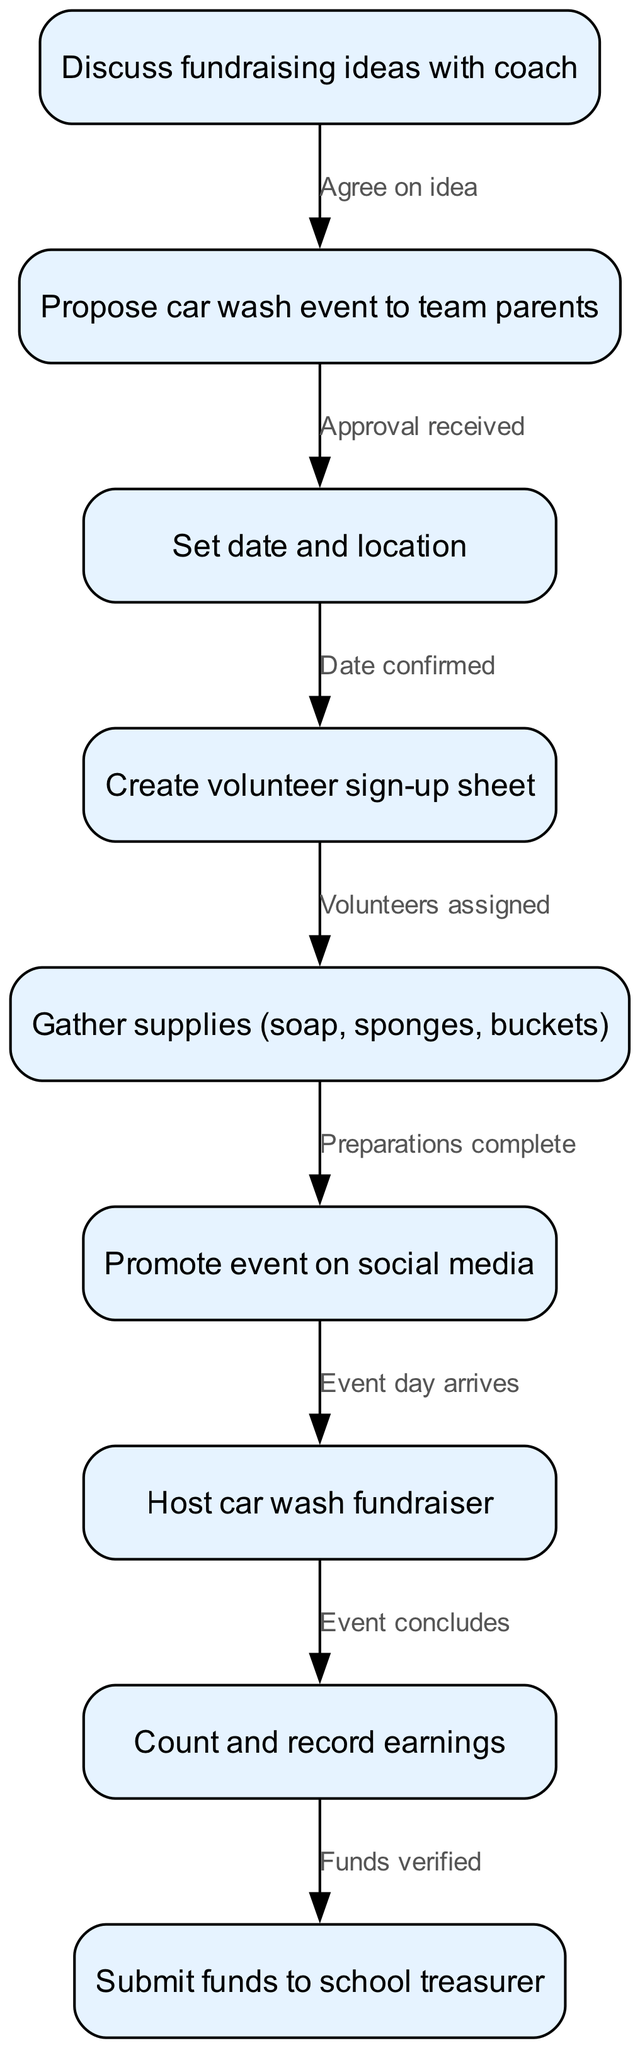What is the first step in organizing the fundraising event? The diagram indicates that the first step involves discussing fundraising ideas with the coach. This is represented as the initial node in the flowchart.
Answer: Discuss fundraising ideas with coach How many nodes are there in the diagram? To find the number of nodes, we can count each distinct action or step listed in the nodes section of the diagram. There are a total of nine nodes.
Answer: 9 What is the last action taken after hosting the car wash fundraiser? The final action in the flowchart after hosting the car wash fundraiser is counting and recording the earnings. This is shown as the last step before submitting the funds.
Answer: Count and record earnings What happens after proposing the car wash event to team parents? After proposing the car wash event to team parents, the next step is to receive approval for the event. This transition is marked by the edge connecting these two nodes.
Answer: Approval received Which step occurs directly after creating a volunteer sign-up sheet? According to the diagram, the step that occurs directly after creating a volunteer sign-up sheet is gathering supplies such as soap, sponges, and buckets. This is indicated by the edge connecting these two nodes.
Answer: Gather supplies (soap, sponges, buckets) What is the relationship between "Host car wash fundraiser" and "Count and record earnings"? The relationship is sequential; after the event is hosted, the next step is to count and record earnings. This shows a direct flow from one action to the next.
Answer: Event concludes How many edges connect the nodes in the diagram? To determine the number of edges, we can count the connections that exist between the nodes from the edges section of the diagram. There are a total of eight edges.
Answer: 8 What must be done before promoting the event on social media? Before promoting the event on social media, all preparations must be completed, which includes gathering supplies and organizing volunteers. This step is essential to ensure a successful promotion.
Answer: Preparations complete What step follows "Date confirmed"? The step that follows "Date confirmed" is creating a volunteer sign-up sheet, establishing the next logical action in the preparation process.
Answer: Create volunteer sign-up sheet 